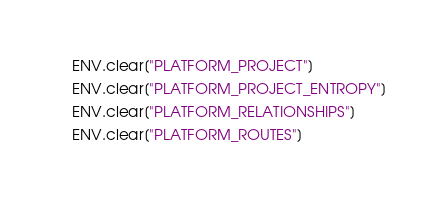<code> <loc_0><loc_0><loc_500><loc_500><_Ruby_>    ENV.clear["PLATFORM_PROJECT"]
    ENV.clear["PLATFORM_PROJECT_ENTROPY"]
    ENV.clear["PLATFORM_RELATIONSHIPS"]
    ENV.clear["PLATFORM_ROUTES"]</code> 